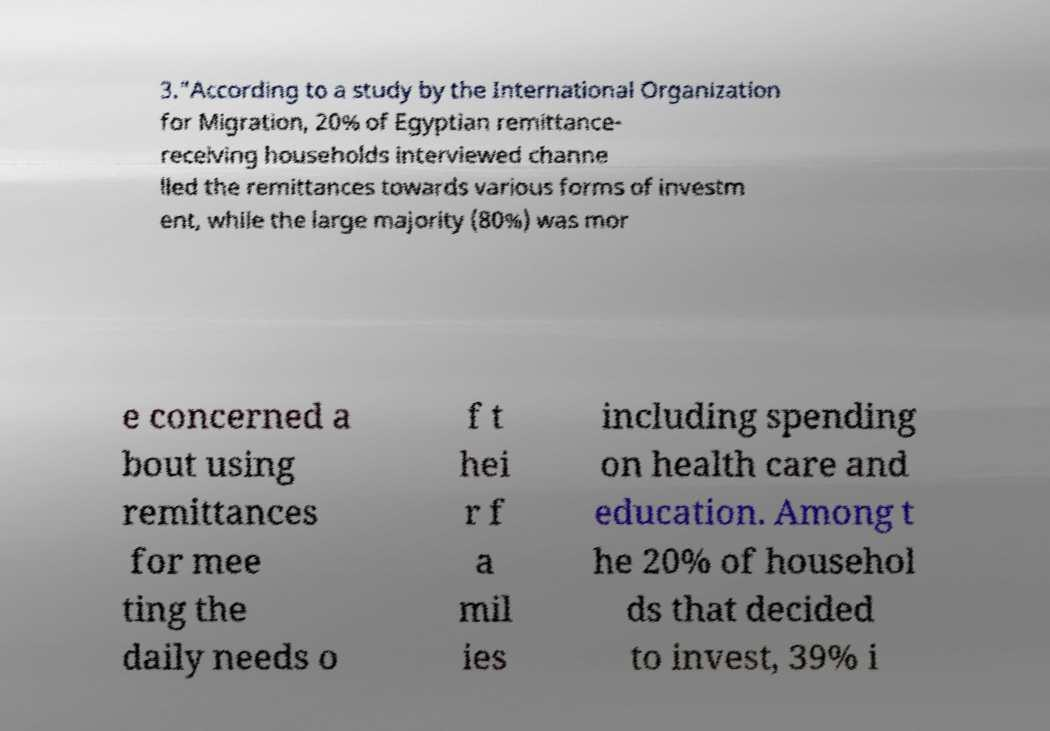Could you assist in decoding the text presented in this image and type it out clearly? 3.”According to a study by the International Organization for Migration, 20% of Egyptian remittance- receiving households interviewed channe lled the remittances towards various forms of investm ent, while the large majority (80%) was mor e concerned a bout using remittances for mee ting the daily needs o f t hei r f a mil ies including spending on health care and education. Among t he 20% of househol ds that decided to invest, 39% i 